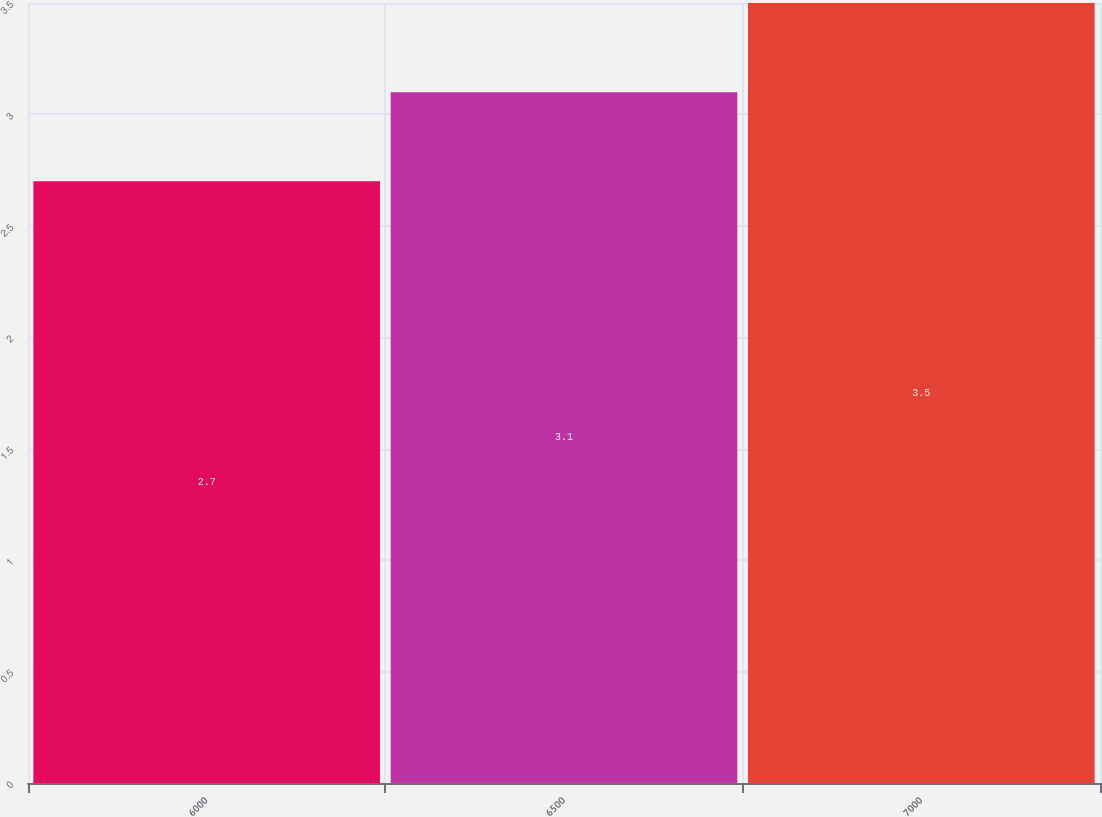Convert chart to OTSL. <chart><loc_0><loc_0><loc_500><loc_500><bar_chart><fcel>6000<fcel>6500<fcel>7000<nl><fcel>2.7<fcel>3.1<fcel>3.5<nl></chart> 